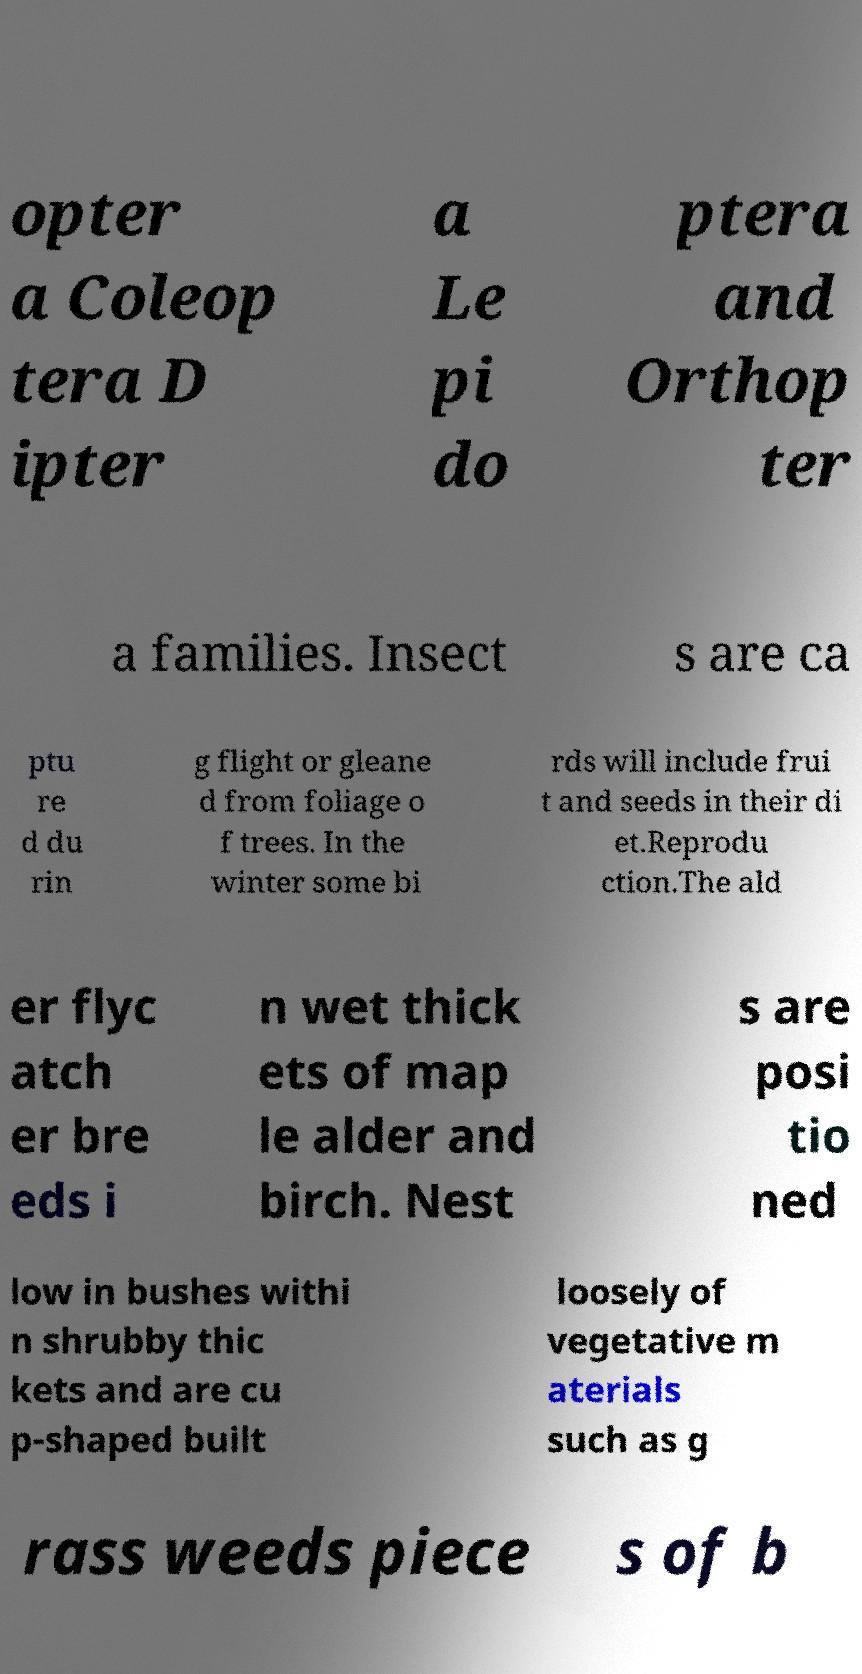For documentation purposes, I need the text within this image transcribed. Could you provide that? opter a Coleop tera D ipter a Le pi do ptera and Orthop ter a families. Insect s are ca ptu re d du rin g flight or gleane d from foliage o f trees. In the winter some bi rds will include frui t and seeds in their di et.Reprodu ction.The ald er flyc atch er bre eds i n wet thick ets of map le alder and birch. Nest s are posi tio ned low in bushes withi n shrubby thic kets and are cu p-shaped built loosely of vegetative m aterials such as g rass weeds piece s of b 